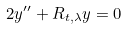Convert formula to latex. <formula><loc_0><loc_0><loc_500><loc_500>2 y ^ { \prime \prime } + R _ { t , \lambda } y = 0</formula> 